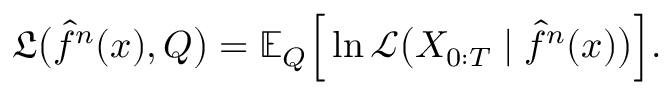<formula> <loc_0><loc_0><loc_500><loc_500>\mathfrak { L } \left ( \hat { f } ^ { n } ( x ) , Q \right ) = \mathbb { E } _ { Q } \left [ \ln \ m a t h s c r { L } \left ( X _ { 0 \colon T } | \hat { f } ^ { n } ( x ) \right ) \right ] .</formula> 